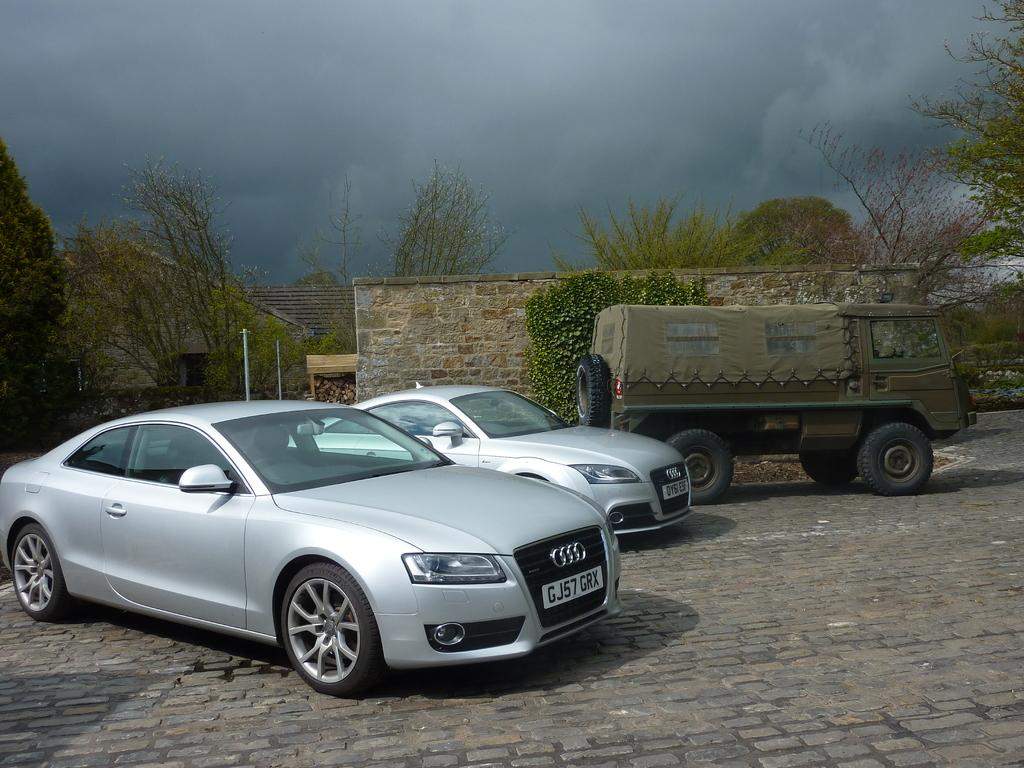What types of objects are present in the image? There are vehicles in the image. What can be seen in the vicinity of the vehicles? There are many trees to the side of the vehicles. What structures are visible in the image? There is a wall and a hut in the image. What is visible in the background of the image? The sky is visible in the background of the image, and it appears to be cloudy. What type of hammer is being used to fix the cable in the image? There is no hammer or cable present in the image. What part of the body is visible in the image? There are no visible human or animal body parts in the image. 